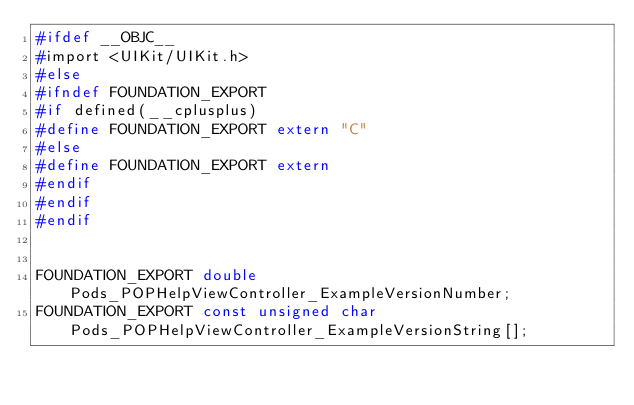Convert code to text. <code><loc_0><loc_0><loc_500><loc_500><_C_>#ifdef __OBJC__
#import <UIKit/UIKit.h>
#else
#ifndef FOUNDATION_EXPORT
#if defined(__cplusplus)
#define FOUNDATION_EXPORT extern "C"
#else
#define FOUNDATION_EXPORT extern
#endif
#endif
#endif


FOUNDATION_EXPORT double Pods_POPHelpViewController_ExampleVersionNumber;
FOUNDATION_EXPORT const unsigned char Pods_POPHelpViewController_ExampleVersionString[];

</code> 